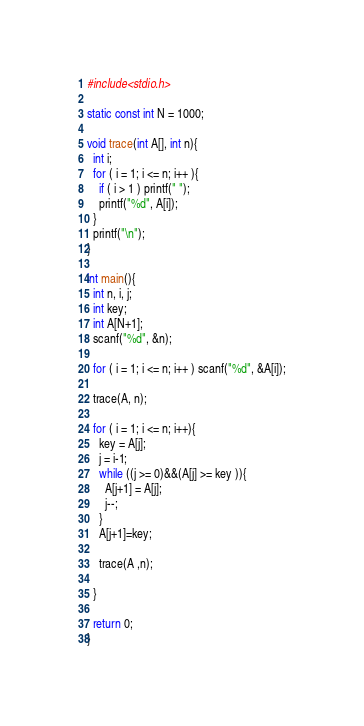Convert code to text. <code><loc_0><loc_0><loc_500><loc_500><_C_>#include<stdio.h>

static const int N = 1000;

void trace(int A[], int n){
  int i;
  for ( i = 1; i <= n; i++ ){
    if ( i > 1 ) printf(" ");
    printf("%d", A[i]);
  }
  printf("\n");
}

int main(){
  int n, i, j;
  int key;
  int A[N+1];
  scanf("%d", &n);

  for ( i = 1; i <= n; i++ ) scanf("%d", &A[i]);

  trace(A, n);

  for ( i = 1; i <= n; i++){
    key = A[j];
    j = i-1;
    while ((j >= 0)&&(A[j] >= key )){
      A[j+1] = A[j];
      j--;
    }
    A[j+1]=key;

    trace(A ,n);

  }

  return 0;
}</code> 